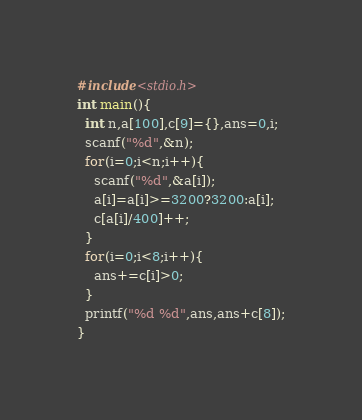Convert code to text. <code><loc_0><loc_0><loc_500><loc_500><_C_>#include<stdio.h>
int main(){
  int n,a[100],c[9]={},ans=0,i;
  scanf("%d",&n);
  for(i=0;i<n;i++){
    scanf("%d",&a[i]);
    a[i]=a[i]>=3200?3200:a[i];
    c[a[i]/400]++;
  }
  for(i=0;i<8;i++){
    ans+=c[i]>0;
  }
  printf("%d %d",ans,ans+c[8]);
}</code> 